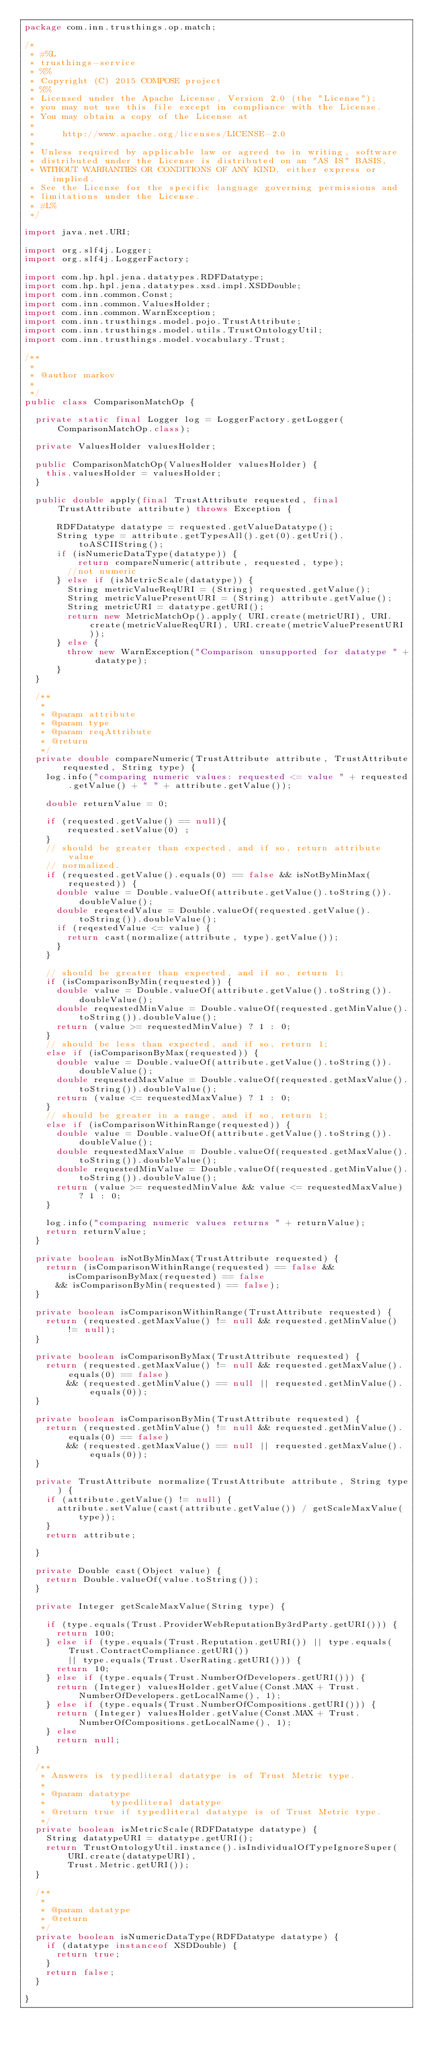<code> <loc_0><loc_0><loc_500><loc_500><_Java_>package com.inn.trusthings.op.match;

/*
 * #%L
 * trusthings-service
 * %%
 * Copyright (C) 2015 COMPOSE project
 * %%
 * Licensed under the Apache License, Version 2.0 (the "License");
 * you may not use this file except in compliance with the License.
 * You may obtain a copy of the License at
 * 
 *     http://www.apache.org/licenses/LICENSE-2.0
 * 
 * Unless required by applicable law or agreed to in writing, software
 * distributed under the License is distributed on an "AS IS" BASIS,
 * WITHOUT WARRANTIES OR CONDITIONS OF ANY KIND, either express or implied.
 * See the License for the specific language governing permissions and
 * limitations under the License.
 * #L%
 */

import java.net.URI;

import org.slf4j.Logger;
import org.slf4j.LoggerFactory;

import com.hp.hpl.jena.datatypes.RDFDatatype;
import com.hp.hpl.jena.datatypes.xsd.impl.XSDDouble;
import com.inn.common.Const;
import com.inn.common.ValuesHolder;
import com.inn.common.WarnException;
import com.inn.trusthings.model.pojo.TrustAttribute;
import com.inn.trusthings.model.utils.TrustOntologyUtil;
import com.inn.trusthings.model.vocabulary.Trust;

/**
 * 
 * @author markov
 * 
 */
public class ComparisonMatchOp {

	private static final Logger log = LoggerFactory.getLogger(ComparisonMatchOp.class);

	private ValuesHolder valuesHolder;

	public ComparisonMatchOp(ValuesHolder valuesHolder) {
		this.valuesHolder = valuesHolder;
	}

	public double apply(final TrustAttribute requested, final TrustAttribute attribute) throws Exception {

			RDFDatatype datatype = requested.getValueDatatype();
			String type = attribute.getTypesAll().get(0).getUri().toASCIIString();
			if (isNumericDataType(datatype)) {
					return compareNumeric(attribute, requested, type);
				//not numeric
			} else if (isMetricScale(datatype)) {
				String metricValueReqURI = (String) requested.getValue();
				String metricValuePresentURI = (String) attribute.getValue();
				String metricURI = datatype.getURI();
				return new MetricMatchOp().apply( URI.create(metricURI), URI.create(metricValueReqURI), URI.create(metricValuePresentURI));
			} else {
				throw new WarnException("Comparison unsupported for datatype " + datatype);
			}
	}

	/**
	 * 
	 * @param attribute
	 * @param type
	 * @param reqAttribute
	 * @return
	 */
	private double compareNumeric(TrustAttribute attribute, TrustAttribute requested, String type) {
		log.info("comparing numeric values: requested <= value " + requested.getValue() + " " + attribute.getValue());

		double returnValue = 0;

		if (requested.getValue() == null){
				requested.setValue(0) ;
		}
		// should be greater than expected, and if so, return attribute value
		// normalized.
		if (requested.getValue().equals(0) == false && isNotByMinMax(requested)) {
			double value = Double.valueOf(attribute.getValue().toString()).doubleValue();
			double reqestedValue = Double.valueOf(requested.getValue().toString()).doubleValue();
			if (reqestedValue <= value) {
				return cast(normalize(attribute, type).getValue());
			}
		}

		// should be greater than expected, and if so, return 1;
		if (isComparisonByMin(requested)) {
			double value = Double.valueOf(attribute.getValue().toString()).doubleValue();
			double requestedMinValue = Double.valueOf(requested.getMinValue().toString()).doubleValue();
			return (value >= requestedMinValue) ? 1 : 0;
		}
		// should be less than expected, and if so, return 1;
		else if (isComparisonByMax(requested)) {
			double value = Double.valueOf(attribute.getValue().toString()).doubleValue();
			double requestedMaxValue = Double.valueOf(requested.getMaxValue().toString()).doubleValue();
			return (value <= requestedMaxValue) ? 1 : 0;
		}
		// should be greater in a range, and if so, return 1;
		else if (isComparisonWithinRange(requested)) {
			double value = Double.valueOf(attribute.getValue().toString()).doubleValue();
			double requestedMaxValue = Double.valueOf(requested.getMaxValue().toString()).doubleValue();
			double requestedMinValue = Double.valueOf(requested.getMinValue().toString()).doubleValue();
			return (value >= requestedMinValue && value <= requestedMaxValue) ? 1 : 0;
		}

		log.info("comparing numeric values returns " + returnValue);
		return returnValue;
	}

	private boolean isNotByMinMax(TrustAttribute requested) {
		return (isComparisonWithinRange(requested) == false && isComparisonByMax(requested) == false
			&& isComparisonByMin(requested) == false);
	}

	private boolean isComparisonWithinRange(TrustAttribute requested) {
		return (requested.getMaxValue() != null && requested.getMinValue() != null);
	}

	private boolean isComparisonByMax(TrustAttribute requested) {
		return (requested.getMaxValue() != null && requested.getMaxValue().equals(0) == false)
				&& (requested.getMinValue() == null || requested.getMinValue().equals(0));
	}

	private boolean isComparisonByMin(TrustAttribute requested) {
		return (requested.getMinValue() != null && requested.getMinValue().equals(0) == false)
				&& (requested.getMaxValue() == null || requested.getMaxValue().equals(0));
	}

	private TrustAttribute normalize(TrustAttribute attribute, String type) {
		if (attribute.getValue() != null) {
			attribute.setValue(cast(attribute.getValue()) / getScaleMaxValue(type));
		}
		return attribute;

	}

	private Double cast(Object value) {
		return Double.valueOf(value.toString());
	}

	private Integer getScaleMaxValue(String type) {

		if (type.equals(Trust.ProviderWebReputationBy3rdParty.getURI())) {
			return 100;
		} else if (type.equals(Trust.Reputation.getURI()) || type.equals(Trust.ContractCompliance.getURI())
				|| type.equals(Trust.UserRating.getURI())) {
			return 10;
		} else if (type.equals(Trust.NumberOfDevelopers.getURI())) {
			return (Integer) valuesHolder.getValue(Const.MAX + Trust.NumberOfDevelopers.getLocalName(), 1);
		} else if (type.equals(Trust.NumberOfCompositions.getURI())) {
			return (Integer) valuesHolder.getValue(Const.MAX + Trust.NumberOfCompositions.getLocalName(), 1);
		} else
			return null;
	}

	/**
	 * Answers is typedliteral datatype is of Trust Metric type.
	 * 
	 * @param datatype
	 *            typedliteral datatype
	 * @return true if typedliteral datatype is of Trust Metric type.
	 */
	private boolean isMetricScale(RDFDatatype datatype) {
		String datatypeURI = datatype.getURI();
		return TrustOntologyUtil.instance().isIndividualOfTypeIgnoreSuper(URI.create(datatypeURI),
				Trust.Metric.getURI());
	}

	/**
	 * 
	 * @param datatype
	 * @return
	 */
	private boolean isNumericDataType(RDFDatatype datatype) {
		if (datatype instanceof XSDDouble) {
			return true;
		}
		return false;
	}

}
</code> 